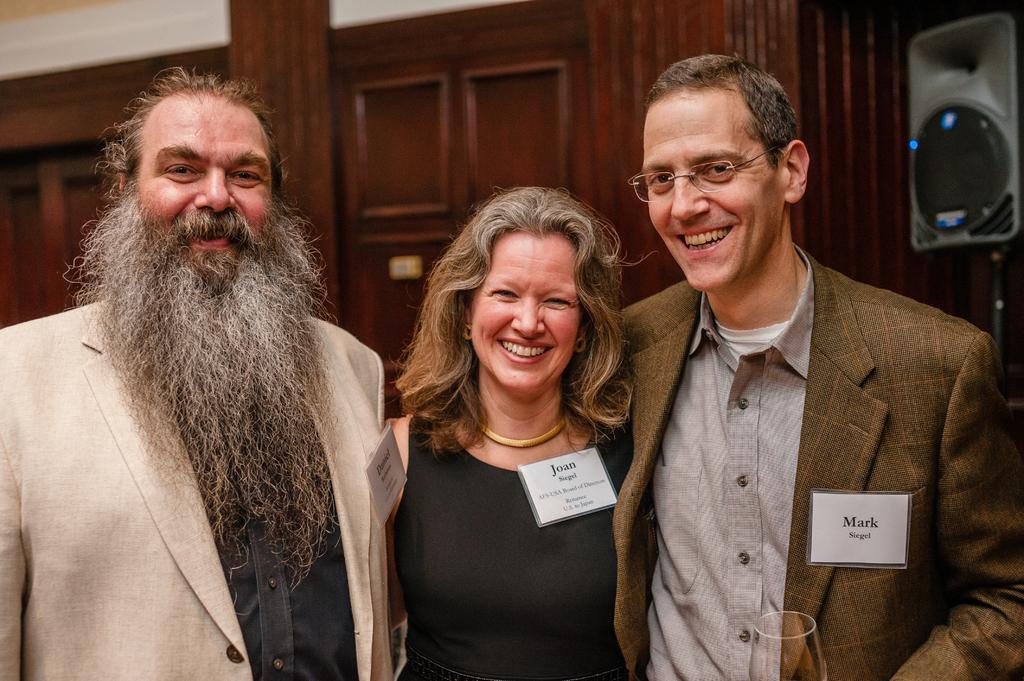Can you describe this image briefly? In this picture I can see few people standing with a smile on their faces and I can see a glass and I can see a speaker on the top right corner and looks like cupboards in the back. 